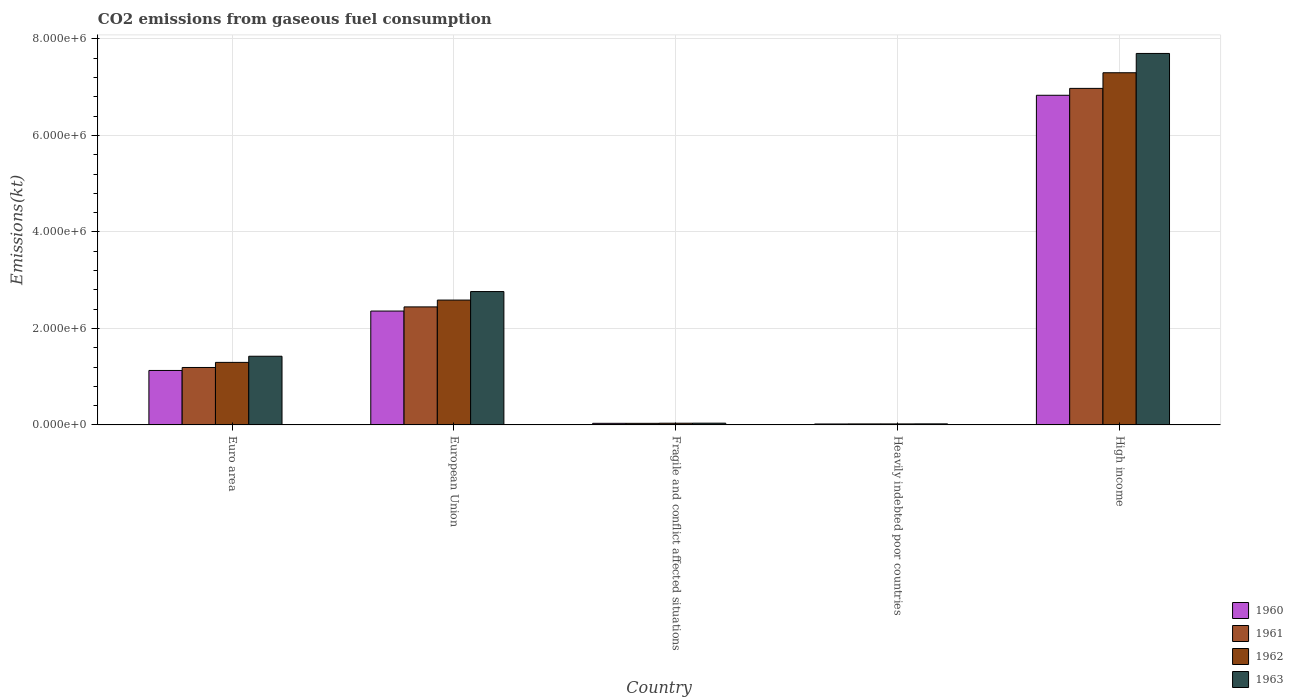How many different coloured bars are there?
Keep it short and to the point. 4. How many groups of bars are there?
Your answer should be compact. 5. Are the number of bars per tick equal to the number of legend labels?
Provide a short and direct response. Yes. How many bars are there on the 2nd tick from the left?
Offer a very short reply. 4. In how many cases, is the number of bars for a given country not equal to the number of legend labels?
Your answer should be very brief. 0. What is the amount of CO2 emitted in 1962 in Fragile and conflict affected situations?
Make the answer very short. 3.54e+04. Across all countries, what is the maximum amount of CO2 emitted in 1961?
Provide a succinct answer. 6.98e+06. Across all countries, what is the minimum amount of CO2 emitted in 1961?
Your response must be concise. 2.05e+04. In which country was the amount of CO2 emitted in 1963 maximum?
Offer a very short reply. High income. In which country was the amount of CO2 emitted in 1961 minimum?
Offer a terse response. Heavily indebted poor countries. What is the total amount of CO2 emitted in 1962 in the graph?
Make the answer very short. 1.12e+07. What is the difference between the amount of CO2 emitted in 1960 in Euro area and that in Heavily indebted poor countries?
Offer a very short reply. 1.11e+06. What is the difference between the amount of CO2 emitted in 1963 in Euro area and the amount of CO2 emitted in 1960 in Fragile and conflict affected situations?
Your response must be concise. 1.39e+06. What is the average amount of CO2 emitted in 1961 per country?
Make the answer very short. 2.13e+06. What is the difference between the amount of CO2 emitted of/in 1961 and amount of CO2 emitted of/in 1960 in Euro area?
Ensure brevity in your answer.  6.20e+04. What is the ratio of the amount of CO2 emitted in 1962 in Fragile and conflict affected situations to that in Heavily indebted poor countries?
Offer a very short reply. 1.72. Is the amount of CO2 emitted in 1962 in Euro area less than that in High income?
Your answer should be compact. Yes. Is the difference between the amount of CO2 emitted in 1961 in European Union and Fragile and conflict affected situations greater than the difference between the amount of CO2 emitted in 1960 in European Union and Fragile and conflict affected situations?
Your answer should be compact. Yes. What is the difference between the highest and the second highest amount of CO2 emitted in 1963?
Provide a succinct answer. -6.28e+06. What is the difference between the highest and the lowest amount of CO2 emitted in 1962?
Provide a short and direct response. 7.28e+06. In how many countries, is the amount of CO2 emitted in 1962 greater than the average amount of CO2 emitted in 1962 taken over all countries?
Make the answer very short. 2. Is it the case that in every country, the sum of the amount of CO2 emitted in 1963 and amount of CO2 emitted in 1961 is greater than the sum of amount of CO2 emitted in 1962 and amount of CO2 emitted in 1960?
Make the answer very short. No. What does the 3rd bar from the left in High income represents?
Provide a short and direct response. 1962. What does the 3rd bar from the right in Euro area represents?
Ensure brevity in your answer.  1961. Are all the bars in the graph horizontal?
Offer a very short reply. No. Does the graph contain any zero values?
Your answer should be compact. No. Does the graph contain grids?
Ensure brevity in your answer.  Yes. What is the title of the graph?
Offer a terse response. CO2 emissions from gaseous fuel consumption. What is the label or title of the Y-axis?
Provide a short and direct response. Emissions(kt). What is the Emissions(kt) in 1960 in Euro area?
Ensure brevity in your answer.  1.13e+06. What is the Emissions(kt) of 1961 in Euro area?
Your answer should be very brief. 1.19e+06. What is the Emissions(kt) of 1962 in Euro area?
Offer a very short reply. 1.30e+06. What is the Emissions(kt) of 1963 in Euro area?
Give a very brief answer. 1.42e+06. What is the Emissions(kt) of 1960 in European Union?
Ensure brevity in your answer.  2.36e+06. What is the Emissions(kt) in 1961 in European Union?
Ensure brevity in your answer.  2.45e+06. What is the Emissions(kt) in 1962 in European Union?
Give a very brief answer. 2.59e+06. What is the Emissions(kt) of 1963 in European Union?
Provide a succinct answer. 2.76e+06. What is the Emissions(kt) of 1960 in Fragile and conflict affected situations?
Offer a very short reply. 3.30e+04. What is the Emissions(kt) of 1961 in Fragile and conflict affected situations?
Your response must be concise. 3.26e+04. What is the Emissions(kt) in 1962 in Fragile and conflict affected situations?
Ensure brevity in your answer.  3.54e+04. What is the Emissions(kt) in 1963 in Fragile and conflict affected situations?
Provide a short and direct response. 3.63e+04. What is the Emissions(kt) in 1960 in Heavily indebted poor countries?
Your response must be concise. 1.95e+04. What is the Emissions(kt) in 1961 in Heavily indebted poor countries?
Provide a succinct answer. 2.05e+04. What is the Emissions(kt) in 1962 in Heavily indebted poor countries?
Your answer should be very brief. 2.06e+04. What is the Emissions(kt) of 1963 in Heavily indebted poor countries?
Offer a terse response. 2.17e+04. What is the Emissions(kt) in 1960 in High income?
Keep it short and to the point. 6.83e+06. What is the Emissions(kt) in 1961 in High income?
Your answer should be very brief. 6.98e+06. What is the Emissions(kt) in 1962 in High income?
Provide a succinct answer. 7.30e+06. What is the Emissions(kt) of 1963 in High income?
Offer a very short reply. 7.70e+06. Across all countries, what is the maximum Emissions(kt) of 1960?
Ensure brevity in your answer.  6.83e+06. Across all countries, what is the maximum Emissions(kt) in 1961?
Keep it short and to the point. 6.98e+06. Across all countries, what is the maximum Emissions(kt) in 1962?
Make the answer very short. 7.30e+06. Across all countries, what is the maximum Emissions(kt) in 1963?
Your answer should be compact. 7.70e+06. Across all countries, what is the minimum Emissions(kt) in 1960?
Provide a succinct answer. 1.95e+04. Across all countries, what is the minimum Emissions(kt) in 1961?
Your answer should be compact. 2.05e+04. Across all countries, what is the minimum Emissions(kt) in 1962?
Your response must be concise. 2.06e+04. Across all countries, what is the minimum Emissions(kt) of 1963?
Your answer should be very brief. 2.17e+04. What is the total Emissions(kt) of 1960 in the graph?
Offer a terse response. 1.04e+07. What is the total Emissions(kt) in 1961 in the graph?
Ensure brevity in your answer.  1.07e+07. What is the total Emissions(kt) of 1962 in the graph?
Give a very brief answer. 1.12e+07. What is the total Emissions(kt) in 1963 in the graph?
Keep it short and to the point. 1.19e+07. What is the difference between the Emissions(kt) of 1960 in Euro area and that in European Union?
Give a very brief answer. -1.23e+06. What is the difference between the Emissions(kt) in 1961 in Euro area and that in European Union?
Keep it short and to the point. -1.26e+06. What is the difference between the Emissions(kt) of 1962 in Euro area and that in European Union?
Offer a very short reply. -1.29e+06. What is the difference between the Emissions(kt) of 1963 in Euro area and that in European Union?
Make the answer very short. -1.34e+06. What is the difference between the Emissions(kt) in 1960 in Euro area and that in Fragile and conflict affected situations?
Keep it short and to the point. 1.10e+06. What is the difference between the Emissions(kt) in 1961 in Euro area and that in Fragile and conflict affected situations?
Make the answer very short. 1.16e+06. What is the difference between the Emissions(kt) in 1962 in Euro area and that in Fragile and conflict affected situations?
Provide a short and direct response. 1.26e+06. What is the difference between the Emissions(kt) of 1963 in Euro area and that in Fragile and conflict affected situations?
Your response must be concise. 1.39e+06. What is the difference between the Emissions(kt) of 1960 in Euro area and that in Heavily indebted poor countries?
Provide a short and direct response. 1.11e+06. What is the difference between the Emissions(kt) in 1961 in Euro area and that in Heavily indebted poor countries?
Provide a succinct answer. 1.17e+06. What is the difference between the Emissions(kt) in 1962 in Euro area and that in Heavily indebted poor countries?
Provide a short and direct response. 1.28e+06. What is the difference between the Emissions(kt) of 1963 in Euro area and that in Heavily indebted poor countries?
Your answer should be very brief. 1.40e+06. What is the difference between the Emissions(kt) in 1960 in Euro area and that in High income?
Your answer should be compact. -5.70e+06. What is the difference between the Emissions(kt) of 1961 in Euro area and that in High income?
Provide a succinct answer. -5.78e+06. What is the difference between the Emissions(kt) in 1962 in Euro area and that in High income?
Offer a very short reply. -6.00e+06. What is the difference between the Emissions(kt) of 1963 in Euro area and that in High income?
Make the answer very short. -6.28e+06. What is the difference between the Emissions(kt) in 1960 in European Union and that in Fragile and conflict affected situations?
Your response must be concise. 2.33e+06. What is the difference between the Emissions(kt) of 1961 in European Union and that in Fragile and conflict affected situations?
Your answer should be very brief. 2.41e+06. What is the difference between the Emissions(kt) of 1962 in European Union and that in Fragile and conflict affected situations?
Make the answer very short. 2.55e+06. What is the difference between the Emissions(kt) in 1963 in European Union and that in Fragile and conflict affected situations?
Make the answer very short. 2.73e+06. What is the difference between the Emissions(kt) of 1960 in European Union and that in Heavily indebted poor countries?
Keep it short and to the point. 2.34e+06. What is the difference between the Emissions(kt) in 1961 in European Union and that in Heavily indebted poor countries?
Keep it short and to the point. 2.43e+06. What is the difference between the Emissions(kt) of 1962 in European Union and that in Heavily indebted poor countries?
Provide a succinct answer. 2.57e+06. What is the difference between the Emissions(kt) in 1963 in European Union and that in Heavily indebted poor countries?
Offer a terse response. 2.74e+06. What is the difference between the Emissions(kt) of 1960 in European Union and that in High income?
Your answer should be very brief. -4.47e+06. What is the difference between the Emissions(kt) in 1961 in European Union and that in High income?
Your answer should be compact. -4.53e+06. What is the difference between the Emissions(kt) in 1962 in European Union and that in High income?
Give a very brief answer. -4.71e+06. What is the difference between the Emissions(kt) of 1963 in European Union and that in High income?
Ensure brevity in your answer.  -4.94e+06. What is the difference between the Emissions(kt) of 1960 in Fragile and conflict affected situations and that in Heavily indebted poor countries?
Keep it short and to the point. 1.35e+04. What is the difference between the Emissions(kt) in 1961 in Fragile and conflict affected situations and that in Heavily indebted poor countries?
Provide a short and direct response. 1.21e+04. What is the difference between the Emissions(kt) in 1962 in Fragile and conflict affected situations and that in Heavily indebted poor countries?
Offer a terse response. 1.49e+04. What is the difference between the Emissions(kt) in 1963 in Fragile and conflict affected situations and that in Heavily indebted poor countries?
Your answer should be compact. 1.46e+04. What is the difference between the Emissions(kt) of 1960 in Fragile and conflict affected situations and that in High income?
Give a very brief answer. -6.80e+06. What is the difference between the Emissions(kt) of 1961 in Fragile and conflict affected situations and that in High income?
Offer a very short reply. -6.94e+06. What is the difference between the Emissions(kt) in 1962 in Fragile and conflict affected situations and that in High income?
Offer a terse response. -7.26e+06. What is the difference between the Emissions(kt) of 1963 in Fragile and conflict affected situations and that in High income?
Ensure brevity in your answer.  -7.66e+06. What is the difference between the Emissions(kt) in 1960 in Heavily indebted poor countries and that in High income?
Offer a terse response. -6.81e+06. What is the difference between the Emissions(kt) in 1961 in Heavily indebted poor countries and that in High income?
Give a very brief answer. -6.95e+06. What is the difference between the Emissions(kt) in 1962 in Heavily indebted poor countries and that in High income?
Keep it short and to the point. -7.28e+06. What is the difference between the Emissions(kt) in 1963 in Heavily indebted poor countries and that in High income?
Your answer should be very brief. -7.68e+06. What is the difference between the Emissions(kt) of 1960 in Euro area and the Emissions(kt) of 1961 in European Union?
Ensure brevity in your answer.  -1.32e+06. What is the difference between the Emissions(kt) of 1960 in Euro area and the Emissions(kt) of 1962 in European Union?
Offer a terse response. -1.46e+06. What is the difference between the Emissions(kt) in 1960 in Euro area and the Emissions(kt) in 1963 in European Union?
Make the answer very short. -1.64e+06. What is the difference between the Emissions(kt) of 1961 in Euro area and the Emissions(kt) of 1962 in European Union?
Provide a succinct answer. -1.40e+06. What is the difference between the Emissions(kt) in 1961 in Euro area and the Emissions(kt) in 1963 in European Union?
Offer a terse response. -1.57e+06. What is the difference between the Emissions(kt) of 1962 in Euro area and the Emissions(kt) of 1963 in European Union?
Give a very brief answer. -1.47e+06. What is the difference between the Emissions(kt) in 1960 in Euro area and the Emissions(kt) in 1961 in Fragile and conflict affected situations?
Make the answer very short. 1.10e+06. What is the difference between the Emissions(kt) in 1960 in Euro area and the Emissions(kt) in 1962 in Fragile and conflict affected situations?
Provide a succinct answer. 1.09e+06. What is the difference between the Emissions(kt) of 1960 in Euro area and the Emissions(kt) of 1963 in Fragile and conflict affected situations?
Give a very brief answer. 1.09e+06. What is the difference between the Emissions(kt) of 1961 in Euro area and the Emissions(kt) of 1962 in Fragile and conflict affected situations?
Your answer should be very brief. 1.16e+06. What is the difference between the Emissions(kt) in 1961 in Euro area and the Emissions(kt) in 1963 in Fragile and conflict affected situations?
Ensure brevity in your answer.  1.15e+06. What is the difference between the Emissions(kt) of 1962 in Euro area and the Emissions(kt) of 1963 in Fragile and conflict affected situations?
Provide a succinct answer. 1.26e+06. What is the difference between the Emissions(kt) in 1960 in Euro area and the Emissions(kt) in 1961 in Heavily indebted poor countries?
Make the answer very short. 1.11e+06. What is the difference between the Emissions(kt) of 1960 in Euro area and the Emissions(kt) of 1962 in Heavily indebted poor countries?
Ensure brevity in your answer.  1.11e+06. What is the difference between the Emissions(kt) in 1960 in Euro area and the Emissions(kt) in 1963 in Heavily indebted poor countries?
Give a very brief answer. 1.11e+06. What is the difference between the Emissions(kt) in 1961 in Euro area and the Emissions(kt) in 1962 in Heavily indebted poor countries?
Your response must be concise. 1.17e+06. What is the difference between the Emissions(kt) in 1961 in Euro area and the Emissions(kt) in 1963 in Heavily indebted poor countries?
Provide a succinct answer. 1.17e+06. What is the difference between the Emissions(kt) in 1962 in Euro area and the Emissions(kt) in 1963 in Heavily indebted poor countries?
Your answer should be very brief. 1.27e+06. What is the difference between the Emissions(kt) of 1960 in Euro area and the Emissions(kt) of 1961 in High income?
Your answer should be compact. -5.85e+06. What is the difference between the Emissions(kt) of 1960 in Euro area and the Emissions(kt) of 1962 in High income?
Provide a short and direct response. -6.17e+06. What is the difference between the Emissions(kt) of 1960 in Euro area and the Emissions(kt) of 1963 in High income?
Provide a short and direct response. -6.57e+06. What is the difference between the Emissions(kt) in 1961 in Euro area and the Emissions(kt) in 1962 in High income?
Give a very brief answer. -6.11e+06. What is the difference between the Emissions(kt) in 1961 in Euro area and the Emissions(kt) in 1963 in High income?
Offer a very short reply. -6.51e+06. What is the difference between the Emissions(kt) of 1962 in Euro area and the Emissions(kt) of 1963 in High income?
Provide a short and direct response. -6.40e+06. What is the difference between the Emissions(kt) in 1960 in European Union and the Emissions(kt) in 1961 in Fragile and conflict affected situations?
Give a very brief answer. 2.33e+06. What is the difference between the Emissions(kt) of 1960 in European Union and the Emissions(kt) of 1962 in Fragile and conflict affected situations?
Your answer should be compact. 2.32e+06. What is the difference between the Emissions(kt) of 1960 in European Union and the Emissions(kt) of 1963 in Fragile and conflict affected situations?
Provide a short and direct response. 2.32e+06. What is the difference between the Emissions(kt) of 1961 in European Union and the Emissions(kt) of 1962 in Fragile and conflict affected situations?
Provide a short and direct response. 2.41e+06. What is the difference between the Emissions(kt) in 1961 in European Union and the Emissions(kt) in 1963 in Fragile and conflict affected situations?
Your answer should be compact. 2.41e+06. What is the difference between the Emissions(kt) in 1962 in European Union and the Emissions(kt) in 1963 in Fragile and conflict affected situations?
Make the answer very short. 2.55e+06. What is the difference between the Emissions(kt) in 1960 in European Union and the Emissions(kt) in 1961 in Heavily indebted poor countries?
Your response must be concise. 2.34e+06. What is the difference between the Emissions(kt) in 1960 in European Union and the Emissions(kt) in 1962 in Heavily indebted poor countries?
Make the answer very short. 2.34e+06. What is the difference between the Emissions(kt) in 1960 in European Union and the Emissions(kt) in 1963 in Heavily indebted poor countries?
Provide a succinct answer. 2.34e+06. What is the difference between the Emissions(kt) of 1961 in European Union and the Emissions(kt) of 1962 in Heavily indebted poor countries?
Your response must be concise. 2.43e+06. What is the difference between the Emissions(kt) in 1961 in European Union and the Emissions(kt) in 1963 in Heavily indebted poor countries?
Give a very brief answer. 2.42e+06. What is the difference between the Emissions(kt) of 1962 in European Union and the Emissions(kt) of 1963 in Heavily indebted poor countries?
Your answer should be very brief. 2.57e+06. What is the difference between the Emissions(kt) of 1960 in European Union and the Emissions(kt) of 1961 in High income?
Give a very brief answer. -4.62e+06. What is the difference between the Emissions(kt) of 1960 in European Union and the Emissions(kt) of 1962 in High income?
Ensure brevity in your answer.  -4.94e+06. What is the difference between the Emissions(kt) of 1960 in European Union and the Emissions(kt) of 1963 in High income?
Offer a very short reply. -5.34e+06. What is the difference between the Emissions(kt) of 1961 in European Union and the Emissions(kt) of 1962 in High income?
Your response must be concise. -4.85e+06. What is the difference between the Emissions(kt) of 1961 in European Union and the Emissions(kt) of 1963 in High income?
Make the answer very short. -5.25e+06. What is the difference between the Emissions(kt) of 1962 in European Union and the Emissions(kt) of 1963 in High income?
Offer a very short reply. -5.11e+06. What is the difference between the Emissions(kt) in 1960 in Fragile and conflict affected situations and the Emissions(kt) in 1961 in Heavily indebted poor countries?
Provide a succinct answer. 1.25e+04. What is the difference between the Emissions(kt) of 1960 in Fragile and conflict affected situations and the Emissions(kt) of 1962 in Heavily indebted poor countries?
Your answer should be compact. 1.25e+04. What is the difference between the Emissions(kt) of 1960 in Fragile and conflict affected situations and the Emissions(kt) of 1963 in Heavily indebted poor countries?
Make the answer very short. 1.13e+04. What is the difference between the Emissions(kt) of 1961 in Fragile and conflict affected situations and the Emissions(kt) of 1962 in Heavily indebted poor countries?
Make the answer very short. 1.20e+04. What is the difference between the Emissions(kt) in 1961 in Fragile and conflict affected situations and the Emissions(kt) in 1963 in Heavily indebted poor countries?
Your answer should be very brief. 1.08e+04. What is the difference between the Emissions(kt) in 1962 in Fragile and conflict affected situations and the Emissions(kt) in 1963 in Heavily indebted poor countries?
Provide a short and direct response. 1.37e+04. What is the difference between the Emissions(kt) in 1960 in Fragile and conflict affected situations and the Emissions(kt) in 1961 in High income?
Provide a succinct answer. -6.94e+06. What is the difference between the Emissions(kt) in 1960 in Fragile and conflict affected situations and the Emissions(kt) in 1962 in High income?
Offer a very short reply. -7.27e+06. What is the difference between the Emissions(kt) of 1960 in Fragile and conflict affected situations and the Emissions(kt) of 1963 in High income?
Offer a very short reply. -7.67e+06. What is the difference between the Emissions(kt) in 1961 in Fragile and conflict affected situations and the Emissions(kt) in 1962 in High income?
Keep it short and to the point. -7.27e+06. What is the difference between the Emissions(kt) in 1961 in Fragile and conflict affected situations and the Emissions(kt) in 1963 in High income?
Provide a succinct answer. -7.67e+06. What is the difference between the Emissions(kt) in 1962 in Fragile and conflict affected situations and the Emissions(kt) in 1963 in High income?
Offer a very short reply. -7.66e+06. What is the difference between the Emissions(kt) in 1960 in Heavily indebted poor countries and the Emissions(kt) in 1961 in High income?
Make the answer very short. -6.96e+06. What is the difference between the Emissions(kt) in 1960 in Heavily indebted poor countries and the Emissions(kt) in 1962 in High income?
Provide a short and direct response. -7.28e+06. What is the difference between the Emissions(kt) of 1960 in Heavily indebted poor countries and the Emissions(kt) of 1963 in High income?
Keep it short and to the point. -7.68e+06. What is the difference between the Emissions(kt) in 1961 in Heavily indebted poor countries and the Emissions(kt) in 1962 in High income?
Your answer should be compact. -7.28e+06. What is the difference between the Emissions(kt) of 1961 in Heavily indebted poor countries and the Emissions(kt) of 1963 in High income?
Your answer should be compact. -7.68e+06. What is the difference between the Emissions(kt) of 1962 in Heavily indebted poor countries and the Emissions(kt) of 1963 in High income?
Your answer should be compact. -7.68e+06. What is the average Emissions(kt) in 1960 per country?
Your response must be concise. 2.07e+06. What is the average Emissions(kt) of 1961 per country?
Provide a short and direct response. 2.13e+06. What is the average Emissions(kt) of 1962 per country?
Make the answer very short. 2.25e+06. What is the average Emissions(kt) of 1963 per country?
Provide a succinct answer. 2.39e+06. What is the difference between the Emissions(kt) of 1960 and Emissions(kt) of 1961 in Euro area?
Provide a short and direct response. -6.20e+04. What is the difference between the Emissions(kt) of 1960 and Emissions(kt) of 1962 in Euro area?
Your answer should be very brief. -1.68e+05. What is the difference between the Emissions(kt) in 1960 and Emissions(kt) in 1963 in Euro area?
Your response must be concise. -2.95e+05. What is the difference between the Emissions(kt) of 1961 and Emissions(kt) of 1962 in Euro area?
Offer a terse response. -1.06e+05. What is the difference between the Emissions(kt) in 1961 and Emissions(kt) in 1963 in Euro area?
Make the answer very short. -2.33e+05. What is the difference between the Emissions(kt) in 1962 and Emissions(kt) in 1963 in Euro area?
Keep it short and to the point. -1.27e+05. What is the difference between the Emissions(kt) in 1960 and Emissions(kt) in 1961 in European Union?
Your answer should be compact. -8.64e+04. What is the difference between the Emissions(kt) in 1960 and Emissions(kt) in 1962 in European Union?
Your response must be concise. -2.28e+05. What is the difference between the Emissions(kt) in 1960 and Emissions(kt) in 1963 in European Union?
Provide a succinct answer. -4.04e+05. What is the difference between the Emissions(kt) of 1961 and Emissions(kt) of 1962 in European Union?
Make the answer very short. -1.41e+05. What is the difference between the Emissions(kt) of 1961 and Emissions(kt) of 1963 in European Union?
Give a very brief answer. -3.18e+05. What is the difference between the Emissions(kt) of 1962 and Emissions(kt) of 1963 in European Union?
Provide a succinct answer. -1.76e+05. What is the difference between the Emissions(kt) of 1960 and Emissions(kt) of 1961 in Fragile and conflict affected situations?
Make the answer very short. 454.55. What is the difference between the Emissions(kt) of 1960 and Emissions(kt) of 1962 in Fragile and conflict affected situations?
Provide a short and direct response. -2385.61. What is the difference between the Emissions(kt) in 1960 and Emissions(kt) in 1963 in Fragile and conflict affected situations?
Your answer should be very brief. -3280.02. What is the difference between the Emissions(kt) in 1961 and Emissions(kt) in 1962 in Fragile and conflict affected situations?
Provide a succinct answer. -2840.15. What is the difference between the Emissions(kt) in 1961 and Emissions(kt) in 1963 in Fragile and conflict affected situations?
Offer a terse response. -3734.57. What is the difference between the Emissions(kt) in 1962 and Emissions(kt) in 1963 in Fragile and conflict affected situations?
Keep it short and to the point. -894.42. What is the difference between the Emissions(kt) in 1960 and Emissions(kt) in 1961 in Heavily indebted poor countries?
Provide a succinct answer. -1040.86. What is the difference between the Emissions(kt) in 1960 and Emissions(kt) in 1962 in Heavily indebted poor countries?
Provide a succinct answer. -1075.55. What is the difference between the Emissions(kt) in 1960 and Emissions(kt) in 1963 in Heavily indebted poor countries?
Provide a short and direct response. -2256.54. What is the difference between the Emissions(kt) in 1961 and Emissions(kt) in 1962 in Heavily indebted poor countries?
Ensure brevity in your answer.  -34.7. What is the difference between the Emissions(kt) in 1961 and Emissions(kt) in 1963 in Heavily indebted poor countries?
Make the answer very short. -1215.68. What is the difference between the Emissions(kt) of 1962 and Emissions(kt) of 1963 in Heavily indebted poor countries?
Offer a very short reply. -1180.99. What is the difference between the Emissions(kt) of 1960 and Emissions(kt) of 1961 in High income?
Keep it short and to the point. -1.43e+05. What is the difference between the Emissions(kt) of 1960 and Emissions(kt) of 1962 in High income?
Offer a terse response. -4.67e+05. What is the difference between the Emissions(kt) of 1960 and Emissions(kt) of 1963 in High income?
Offer a terse response. -8.67e+05. What is the difference between the Emissions(kt) in 1961 and Emissions(kt) in 1962 in High income?
Offer a very short reply. -3.24e+05. What is the difference between the Emissions(kt) in 1961 and Emissions(kt) in 1963 in High income?
Your answer should be compact. -7.24e+05. What is the difference between the Emissions(kt) in 1962 and Emissions(kt) in 1963 in High income?
Keep it short and to the point. -4.00e+05. What is the ratio of the Emissions(kt) of 1960 in Euro area to that in European Union?
Offer a terse response. 0.48. What is the ratio of the Emissions(kt) of 1961 in Euro area to that in European Union?
Your response must be concise. 0.49. What is the ratio of the Emissions(kt) in 1962 in Euro area to that in European Union?
Your answer should be very brief. 0.5. What is the ratio of the Emissions(kt) of 1963 in Euro area to that in European Union?
Make the answer very short. 0.52. What is the ratio of the Emissions(kt) of 1960 in Euro area to that in Fragile and conflict affected situations?
Provide a succinct answer. 34.17. What is the ratio of the Emissions(kt) in 1961 in Euro area to that in Fragile and conflict affected situations?
Give a very brief answer. 36.55. What is the ratio of the Emissions(kt) in 1962 in Euro area to that in Fragile and conflict affected situations?
Your response must be concise. 36.6. What is the ratio of the Emissions(kt) of 1963 in Euro area to that in Fragile and conflict affected situations?
Your response must be concise. 39.2. What is the ratio of the Emissions(kt) of 1960 in Euro area to that in Heavily indebted poor countries?
Give a very brief answer. 57.92. What is the ratio of the Emissions(kt) in 1961 in Euro area to that in Heavily indebted poor countries?
Your answer should be very brief. 58.01. What is the ratio of the Emissions(kt) in 1962 in Euro area to that in Heavily indebted poor countries?
Give a very brief answer. 63.05. What is the ratio of the Emissions(kt) of 1963 in Euro area to that in Heavily indebted poor countries?
Your answer should be very brief. 65.48. What is the ratio of the Emissions(kt) in 1960 in Euro area to that in High income?
Your answer should be compact. 0.17. What is the ratio of the Emissions(kt) in 1961 in Euro area to that in High income?
Ensure brevity in your answer.  0.17. What is the ratio of the Emissions(kt) in 1962 in Euro area to that in High income?
Ensure brevity in your answer.  0.18. What is the ratio of the Emissions(kt) of 1963 in Euro area to that in High income?
Give a very brief answer. 0.18. What is the ratio of the Emissions(kt) of 1960 in European Union to that in Fragile and conflict affected situations?
Provide a succinct answer. 71.45. What is the ratio of the Emissions(kt) of 1961 in European Union to that in Fragile and conflict affected situations?
Offer a terse response. 75.1. What is the ratio of the Emissions(kt) in 1962 in European Union to that in Fragile and conflict affected situations?
Make the answer very short. 73.06. What is the ratio of the Emissions(kt) of 1963 in European Union to that in Fragile and conflict affected situations?
Your response must be concise. 76.12. What is the ratio of the Emissions(kt) of 1960 in European Union to that in Heavily indebted poor countries?
Give a very brief answer. 121.13. What is the ratio of the Emissions(kt) of 1961 in European Union to that in Heavily indebted poor countries?
Keep it short and to the point. 119.2. What is the ratio of the Emissions(kt) in 1962 in European Union to that in Heavily indebted poor countries?
Provide a succinct answer. 125.87. What is the ratio of the Emissions(kt) of 1963 in European Union to that in Heavily indebted poor countries?
Provide a succinct answer. 127.15. What is the ratio of the Emissions(kt) in 1960 in European Union to that in High income?
Your response must be concise. 0.35. What is the ratio of the Emissions(kt) in 1961 in European Union to that in High income?
Ensure brevity in your answer.  0.35. What is the ratio of the Emissions(kt) in 1962 in European Union to that in High income?
Your answer should be very brief. 0.35. What is the ratio of the Emissions(kt) of 1963 in European Union to that in High income?
Your answer should be compact. 0.36. What is the ratio of the Emissions(kt) of 1960 in Fragile and conflict affected situations to that in Heavily indebted poor countries?
Provide a short and direct response. 1.7. What is the ratio of the Emissions(kt) of 1961 in Fragile and conflict affected situations to that in Heavily indebted poor countries?
Offer a very short reply. 1.59. What is the ratio of the Emissions(kt) in 1962 in Fragile and conflict affected situations to that in Heavily indebted poor countries?
Provide a short and direct response. 1.72. What is the ratio of the Emissions(kt) in 1963 in Fragile and conflict affected situations to that in Heavily indebted poor countries?
Your answer should be very brief. 1.67. What is the ratio of the Emissions(kt) in 1960 in Fragile and conflict affected situations to that in High income?
Provide a short and direct response. 0. What is the ratio of the Emissions(kt) in 1961 in Fragile and conflict affected situations to that in High income?
Make the answer very short. 0. What is the ratio of the Emissions(kt) in 1962 in Fragile and conflict affected situations to that in High income?
Keep it short and to the point. 0. What is the ratio of the Emissions(kt) of 1963 in Fragile and conflict affected situations to that in High income?
Your response must be concise. 0. What is the ratio of the Emissions(kt) of 1960 in Heavily indebted poor countries to that in High income?
Make the answer very short. 0. What is the ratio of the Emissions(kt) of 1961 in Heavily indebted poor countries to that in High income?
Provide a short and direct response. 0. What is the ratio of the Emissions(kt) in 1962 in Heavily indebted poor countries to that in High income?
Provide a succinct answer. 0. What is the ratio of the Emissions(kt) in 1963 in Heavily indebted poor countries to that in High income?
Provide a succinct answer. 0. What is the difference between the highest and the second highest Emissions(kt) of 1960?
Make the answer very short. 4.47e+06. What is the difference between the highest and the second highest Emissions(kt) of 1961?
Ensure brevity in your answer.  4.53e+06. What is the difference between the highest and the second highest Emissions(kt) of 1962?
Offer a terse response. 4.71e+06. What is the difference between the highest and the second highest Emissions(kt) in 1963?
Your answer should be compact. 4.94e+06. What is the difference between the highest and the lowest Emissions(kt) of 1960?
Offer a very short reply. 6.81e+06. What is the difference between the highest and the lowest Emissions(kt) of 1961?
Make the answer very short. 6.95e+06. What is the difference between the highest and the lowest Emissions(kt) of 1962?
Your answer should be compact. 7.28e+06. What is the difference between the highest and the lowest Emissions(kt) in 1963?
Keep it short and to the point. 7.68e+06. 